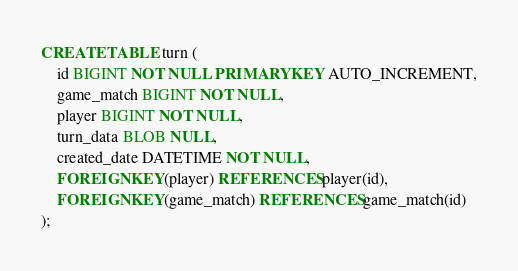<code> <loc_0><loc_0><loc_500><loc_500><_SQL_>CREATE TABLE turn (
	id BIGINT NOT NULL PRIMARY KEY AUTO_INCREMENT,
	game_match BIGINT NOT NULL,
	player BIGINT NOT NULL,
	turn_data BLOB NULL,
	created_date DATETIME NOT NULL,
	FOREIGN KEY(player) REFERENCES player(id),
	FOREIGN KEY(game_match) REFERENCES game_match(id)
);</code> 